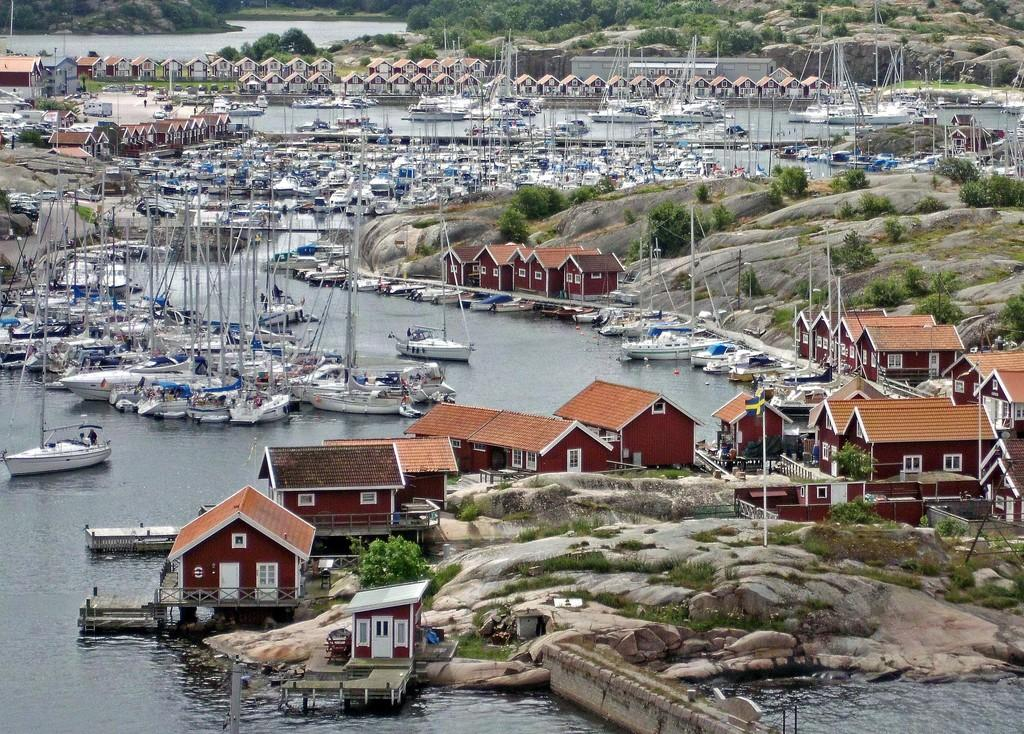What type of structures can be seen in the image? There are sheds in the image. What natural feature is located in the center of the image? There is a river in the center of the image. What is present in the river? There are ships visible in the river. What can be seen in the background of the image? There are trees and a hill in the background of the image. What type of needle is being used to sew the dress in the image? There is no needle or dress present in the image. What type of soup is being served in the image? There is no soup present in the image. 